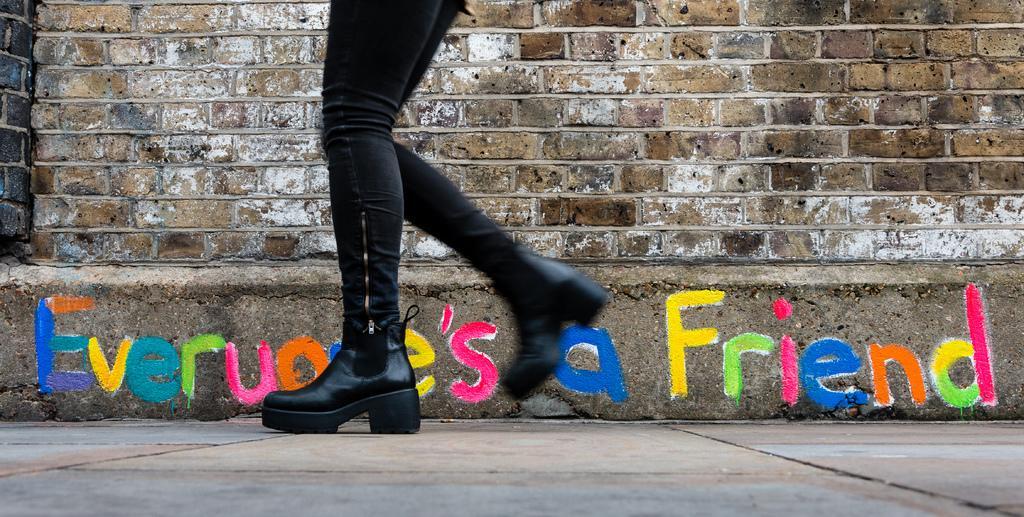Describe this image in one or two sentences. This image consists of a person wearing a black pant and black shoes. At the bottom, there is a road. In the front, we can see a wall on which there is text. 